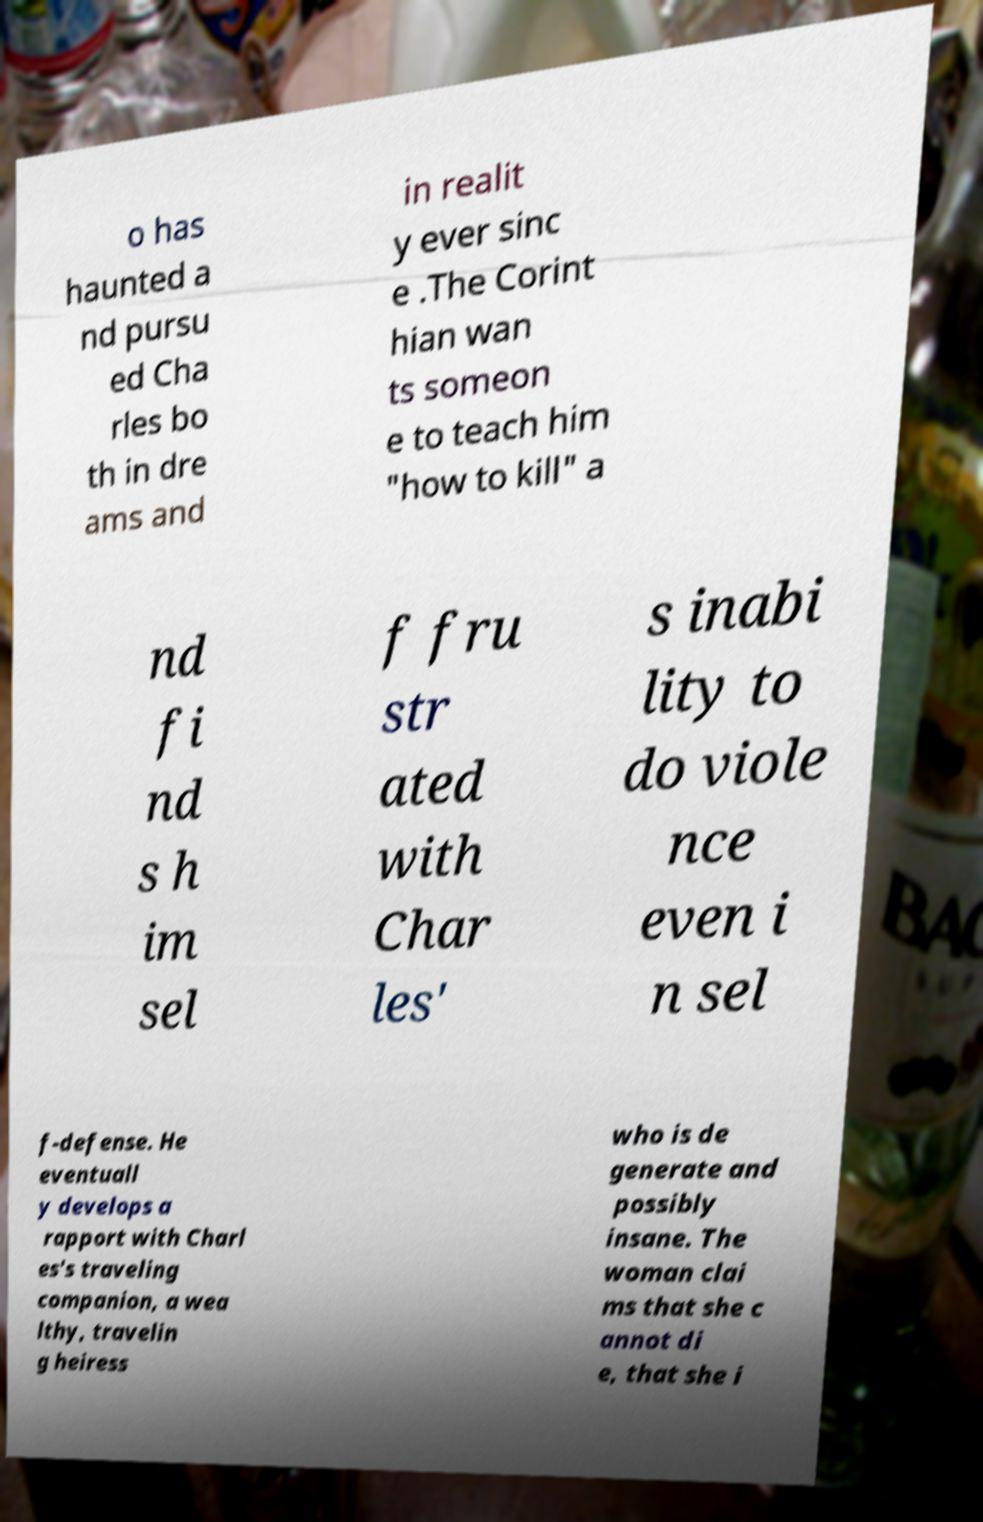Please identify and transcribe the text found in this image. o has haunted a nd pursu ed Cha rles bo th in dre ams and in realit y ever sinc e .The Corint hian wan ts someon e to teach him "how to kill" a nd fi nd s h im sel f fru str ated with Char les' s inabi lity to do viole nce even i n sel f-defense. He eventuall y develops a rapport with Charl es's traveling companion, a wea lthy, travelin g heiress who is de generate and possibly insane. The woman clai ms that she c annot di e, that she i 